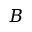<formula> <loc_0><loc_0><loc_500><loc_500>B</formula> 